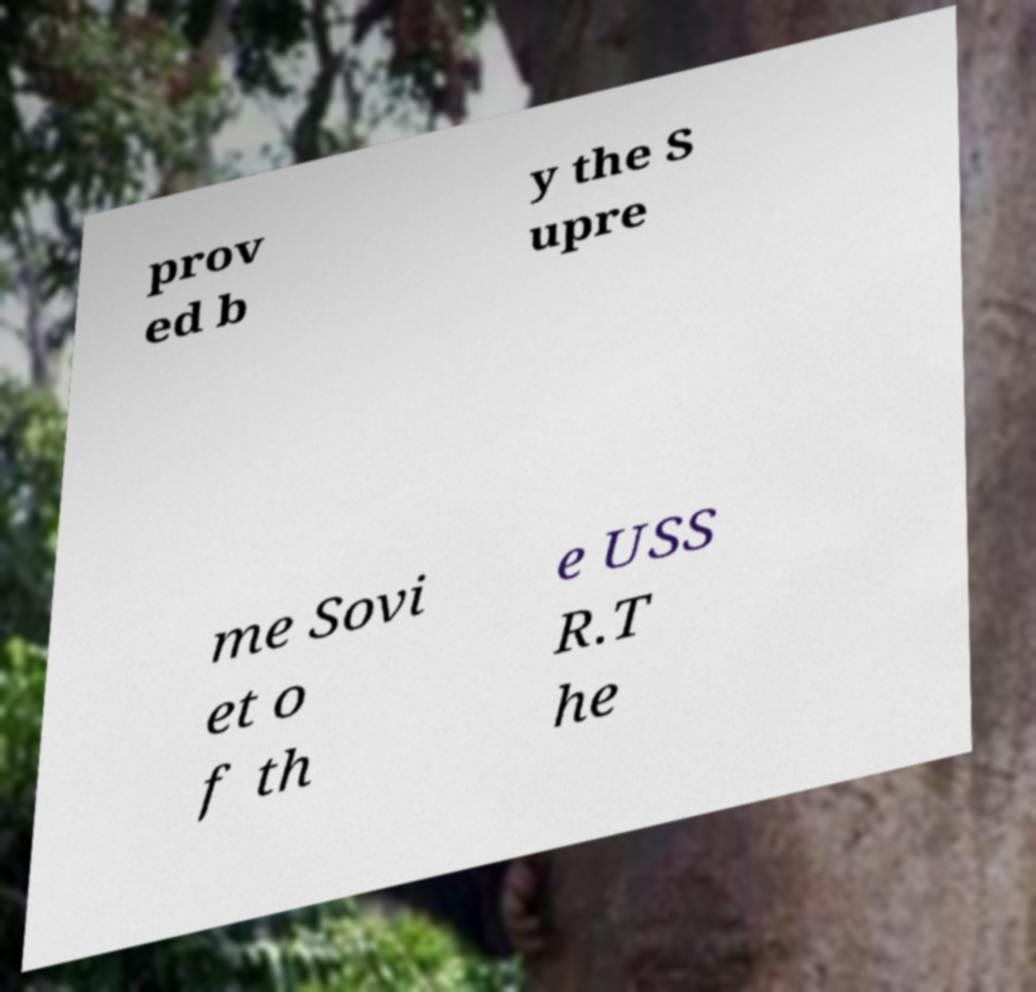I need the written content from this picture converted into text. Can you do that? prov ed b y the S upre me Sovi et o f th e USS R.T he 